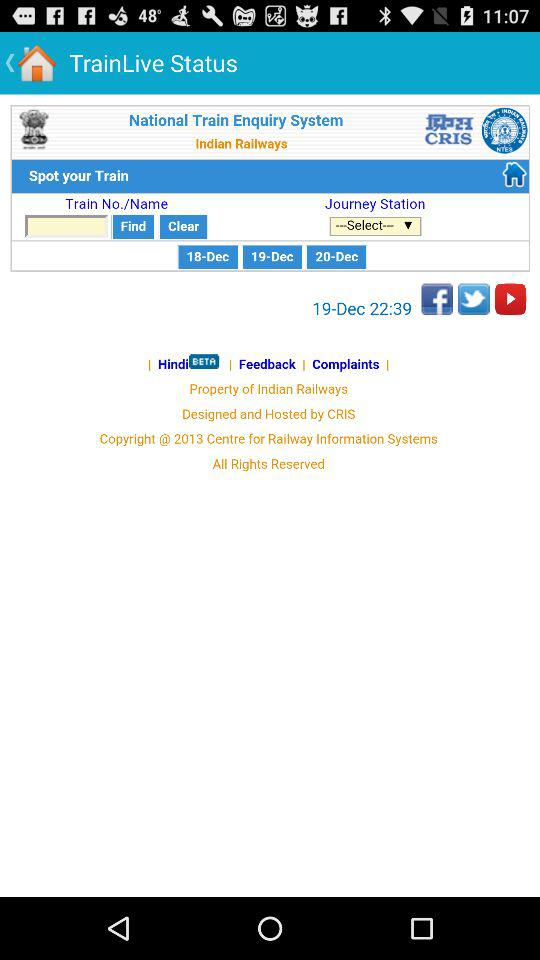What is the mentioned date? The mentioned dates are December 18, December 19 and December 20. 